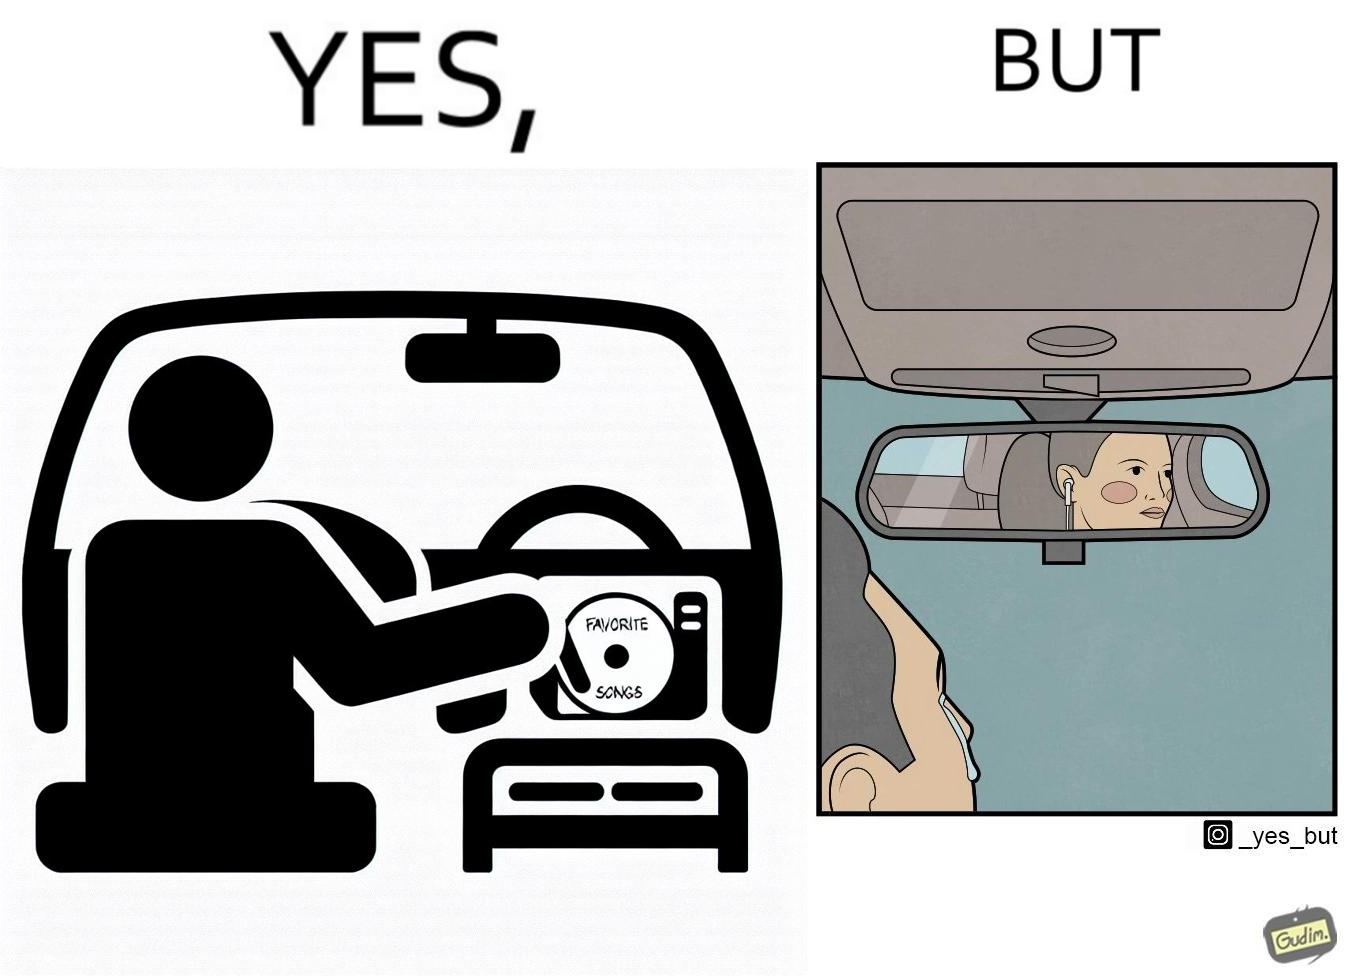What does this image depict? The image is funny, as the driver of the car inserts a CD named "Favorite Songs" into the CD player for the passenger, but the driver is sad on seeing the passenger in the back seat listening to something else on earphones instead. 